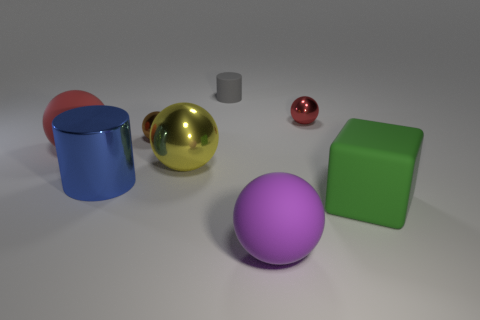How many big objects are either blue things or green shiny spheres?
Your response must be concise. 1. There is a red ball that is right of the cylinder that is right of the large yellow metallic sphere; what is it made of?
Ensure brevity in your answer.  Metal. Are there any small things that have the same material as the large cylinder?
Keep it short and to the point. Yes. Is the brown object made of the same material as the cylinder behind the brown metallic ball?
Offer a terse response. No. There is a metallic cylinder that is the same size as the green thing; what is its color?
Make the answer very short. Blue. There is a red ball that is on the right side of the tiny metallic thing to the left of the purple matte ball; what size is it?
Offer a very short reply. Small. Is the number of purple spheres on the left side of the blue metallic object less than the number of small gray things?
Your response must be concise. Yes. What number of other objects are the same size as the cube?
Provide a succinct answer. 4. Do the thing in front of the green rubber thing and the red metal thing have the same shape?
Keep it short and to the point. Yes. Is the number of matte cylinders behind the green cube greater than the number of small purple rubber spheres?
Make the answer very short. Yes. 